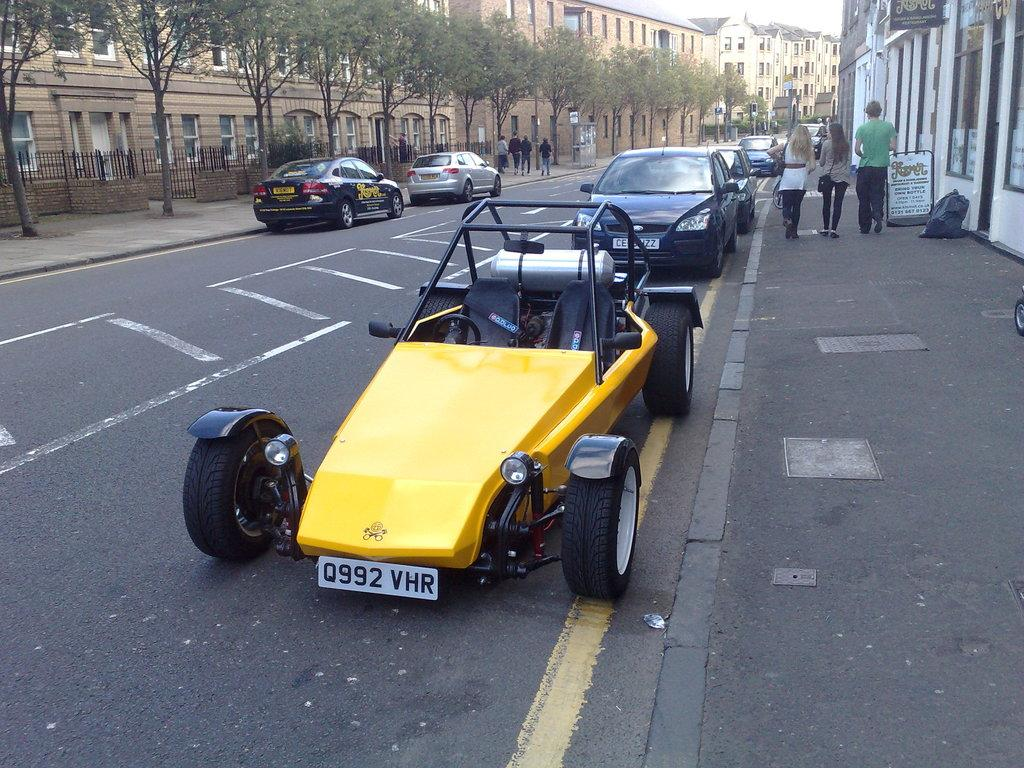Where was the image taken? The image was clicked outside. What can be seen at the top of the image? There are buildings and trees at the top of the image. What is in the middle of the image? There are cars in the middle of the image. What is on the right side of the image? There are persons on the right side of the image. Where is the sink located in the image? There is no sink present in the image. What event is taking place in the image? The image does not depict any specific event, such as a birth. 